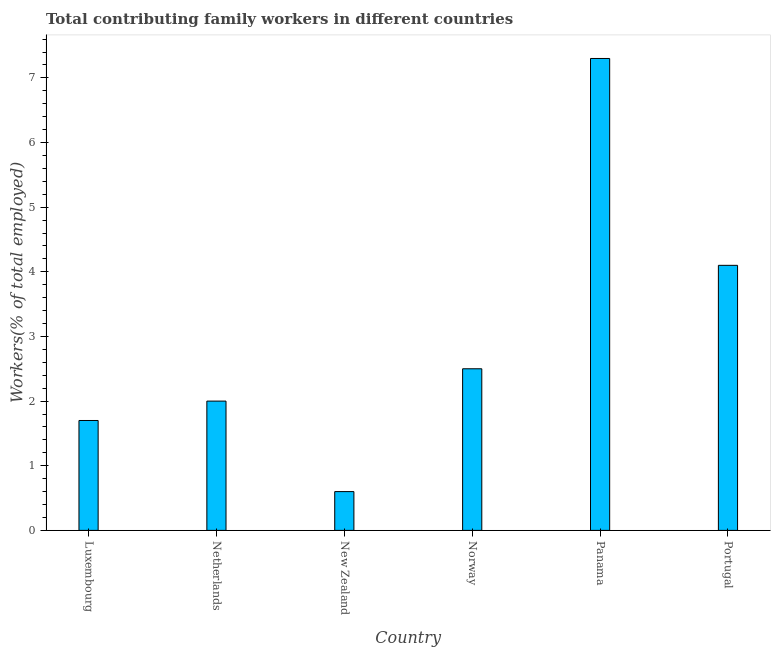Does the graph contain grids?
Your response must be concise. No. What is the title of the graph?
Make the answer very short. Total contributing family workers in different countries. What is the label or title of the Y-axis?
Your answer should be compact. Workers(% of total employed). What is the contributing family workers in New Zealand?
Make the answer very short. 0.6. Across all countries, what is the maximum contributing family workers?
Provide a short and direct response. 7.3. Across all countries, what is the minimum contributing family workers?
Your answer should be very brief. 0.6. In which country was the contributing family workers maximum?
Provide a succinct answer. Panama. In which country was the contributing family workers minimum?
Make the answer very short. New Zealand. What is the sum of the contributing family workers?
Offer a terse response. 18.2. What is the difference between the contributing family workers in Netherlands and Portugal?
Offer a terse response. -2.1. What is the average contributing family workers per country?
Ensure brevity in your answer.  3.03. What is the median contributing family workers?
Give a very brief answer. 2.25. What is the ratio of the contributing family workers in Luxembourg to that in Panama?
Make the answer very short. 0.23. What is the difference between the highest and the second highest contributing family workers?
Ensure brevity in your answer.  3.2. What is the difference between the highest and the lowest contributing family workers?
Provide a short and direct response. 6.7. In how many countries, is the contributing family workers greater than the average contributing family workers taken over all countries?
Keep it short and to the point. 2. Are all the bars in the graph horizontal?
Offer a terse response. No. How many countries are there in the graph?
Provide a succinct answer. 6. What is the difference between two consecutive major ticks on the Y-axis?
Provide a succinct answer. 1. Are the values on the major ticks of Y-axis written in scientific E-notation?
Offer a terse response. No. What is the Workers(% of total employed) of Luxembourg?
Provide a short and direct response. 1.7. What is the Workers(% of total employed) of New Zealand?
Make the answer very short. 0.6. What is the Workers(% of total employed) in Panama?
Your answer should be compact. 7.3. What is the Workers(% of total employed) in Portugal?
Offer a very short reply. 4.1. What is the difference between the Workers(% of total employed) in Luxembourg and Netherlands?
Keep it short and to the point. -0.3. What is the difference between the Workers(% of total employed) in Luxembourg and New Zealand?
Keep it short and to the point. 1.1. What is the difference between the Workers(% of total employed) in Luxembourg and Portugal?
Your answer should be compact. -2.4. What is the difference between the Workers(% of total employed) in Netherlands and New Zealand?
Provide a succinct answer. 1.4. What is the difference between the Workers(% of total employed) in Netherlands and Norway?
Make the answer very short. -0.5. What is the difference between the Workers(% of total employed) in Netherlands and Panama?
Your answer should be compact. -5.3. What is the difference between the Workers(% of total employed) in New Zealand and Norway?
Offer a terse response. -1.9. What is the difference between the Workers(% of total employed) in New Zealand and Panama?
Offer a terse response. -6.7. What is the difference between the Workers(% of total employed) in Norway and Portugal?
Give a very brief answer. -1.6. What is the difference between the Workers(% of total employed) in Panama and Portugal?
Offer a terse response. 3.2. What is the ratio of the Workers(% of total employed) in Luxembourg to that in New Zealand?
Offer a very short reply. 2.83. What is the ratio of the Workers(% of total employed) in Luxembourg to that in Norway?
Keep it short and to the point. 0.68. What is the ratio of the Workers(% of total employed) in Luxembourg to that in Panama?
Provide a short and direct response. 0.23. What is the ratio of the Workers(% of total employed) in Luxembourg to that in Portugal?
Offer a terse response. 0.41. What is the ratio of the Workers(% of total employed) in Netherlands to that in New Zealand?
Your answer should be compact. 3.33. What is the ratio of the Workers(% of total employed) in Netherlands to that in Panama?
Provide a short and direct response. 0.27. What is the ratio of the Workers(% of total employed) in Netherlands to that in Portugal?
Offer a very short reply. 0.49. What is the ratio of the Workers(% of total employed) in New Zealand to that in Norway?
Provide a succinct answer. 0.24. What is the ratio of the Workers(% of total employed) in New Zealand to that in Panama?
Ensure brevity in your answer.  0.08. What is the ratio of the Workers(% of total employed) in New Zealand to that in Portugal?
Your answer should be very brief. 0.15. What is the ratio of the Workers(% of total employed) in Norway to that in Panama?
Give a very brief answer. 0.34. What is the ratio of the Workers(% of total employed) in Norway to that in Portugal?
Provide a succinct answer. 0.61. What is the ratio of the Workers(% of total employed) in Panama to that in Portugal?
Your answer should be compact. 1.78. 